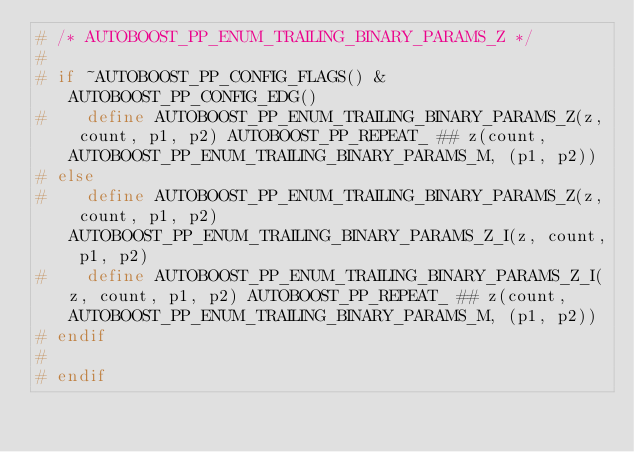<code> <loc_0><loc_0><loc_500><loc_500><_C++_># /* AUTOBOOST_PP_ENUM_TRAILING_BINARY_PARAMS_Z */
#
# if ~AUTOBOOST_PP_CONFIG_FLAGS() & AUTOBOOST_PP_CONFIG_EDG()
#    define AUTOBOOST_PP_ENUM_TRAILING_BINARY_PARAMS_Z(z, count, p1, p2) AUTOBOOST_PP_REPEAT_ ## z(count, AUTOBOOST_PP_ENUM_TRAILING_BINARY_PARAMS_M, (p1, p2))
# else
#    define AUTOBOOST_PP_ENUM_TRAILING_BINARY_PARAMS_Z(z, count, p1, p2) AUTOBOOST_PP_ENUM_TRAILING_BINARY_PARAMS_Z_I(z, count, p1, p2)
#    define AUTOBOOST_PP_ENUM_TRAILING_BINARY_PARAMS_Z_I(z, count, p1, p2) AUTOBOOST_PP_REPEAT_ ## z(count, AUTOBOOST_PP_ENUM_TRAILING_BINARY_PARAMS_M, (p1, p2))
# endif
#
# endif
</code> 